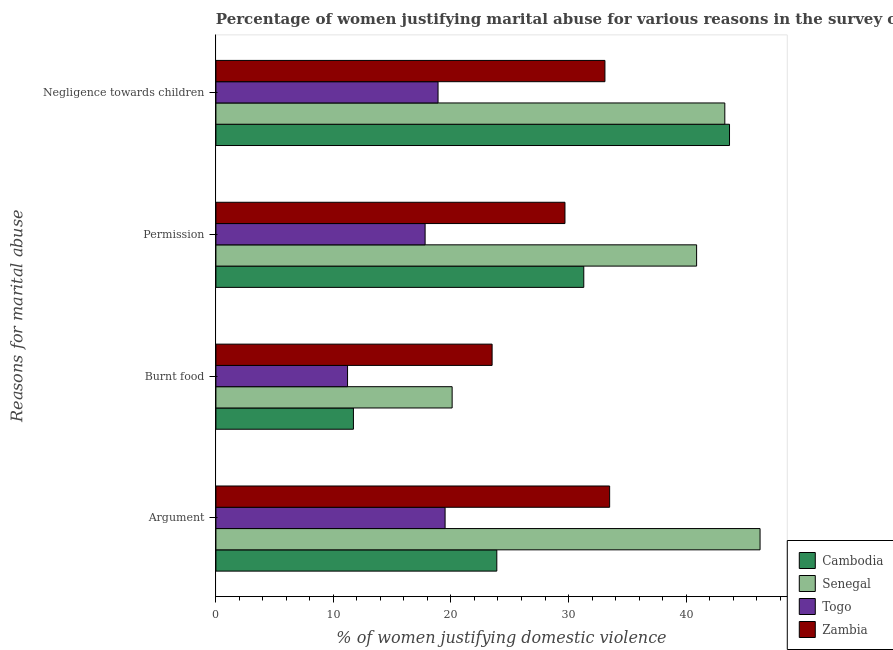How many groups of bars are there?
Provide a short and direct response. 4. Are the number of bars per tick equal to the number of legend labels?
Provide a short and direct response. Yes. Are the number of bars on each tick of the Y-axis equal?
Keep it short and to the point. Yes. How many bars are there on the 3rd tick from the bottom?
Offer a terse response. 4. What is the label of the 1st group of bars from the top?
Your response must be concise. Negligence towards children. What is the percentage of women justifying abuse for going without permission in Zambia?
Keep it short and to the point. 29.7. Across all countries, what is the maximum percentage of women justifying abuse for going without permission?
Ensure brevity in your answer.  40.9. In which country was the percentage of women justifying abuse in the case of an argument maximum?
Your response must be concise. Senegal. In which country was the percentage of women justifying abuse for going without permission minimum?
Provide a succinct answer. Togo. What is the total percentage of women justifying abuse for showing negligence towards children in the graph?
Your answer should be compact. 139. What is the difference between the percentage of women justifying abuse in the case of an argument in Togo and that in Senegal?
Your answer should be compact. -26.8. What is the difference between the percentage of women justifying abuse for showing negligence towards children in Zambia and the percentage of women justifying abuse for burning food in Togo?
Offer a terse response. 21.9. What is the average percentage of women justifying abuse for burning food per country?
Give a very brief answer. 16.62. What is the difference between the percentage of women justifying abuse for showing negligence towards children and percentage of women justifying abuse for burning food in Togo?
Offer a terse response. 7.7. What is the ratio of the percentage of women justifying abuse in the case of an argument in Cambodia to that in Senegal?
Your answer should be compact. 0.52. Is the difference between the percentage of women justifying abuse in the case of an argument in Senegal and Togo greater than the difference between the percentage of women justifying abuse for going without permission in Senegal and Togo?
Offer a very short reply. Yes. What is the difference between the highest and the second highest percentage of women justifying abuse for burning food?
Give a very brief answer. 3.4. In how many countries, is the percentage of women justifying abuse in the case of an argument greater than the average percentage of women justifying abuse in the case of an argument taken over all countries?
Provide a short and direct response. 2. Is it the case that in every country, the sum of the percentage of women justifying abuse in the case of an argument and percentage of women justifying abuse for burning food is greater than the sum of percentage of women justifying abuse for going without permission and percentage of women justifying abuse for showing negligence towards children?
Give a very brief answer. No. What does the 3rd bar from the top in Argument represents?
Offer a terse response. Senegal. What does the 2nd bar from the bottom in Argument represents?
Give a very brief answer. Senegal. Is it the case that in every country, the sum of the percentage of women justifying abuse in the case of an argument and percentage of women justifying abuse for burning food is greater than the percentage of women justifying abuse for going without permission?
Offer a terse response. Yes. How many bars are there?
Make the answer very short. 16. Are all the bars in the graph horizontal?
Provide a succinct answer. Yes. What is the difference between two consecutive major ticks on the X-axis?
Offer a terse response. 10. Are the values on the major ticks of X-axis written in scientific E-notation?
Provide a short and direct response. No. Does the graph contain grids?
Provide a short and direct response. No. Where does the legend appear in the graph?
Your response must be concise. Bottom right. What is the title of the graph?
Give a very brief answer. Percentage of women justifying marital abuse for various reasons in the survey of 2014. What is the label or title of the X-axis?
Make the answer very short. % of women justifying domestic violence. What is the label or title of the Y-axis?
Your response must be concise. Reasons for marital abuse. What is the % of women justifying domestic violence in Cambodia in Argument?
Your answer should be very brief. 23.9. What is the % of women justifying domestic violence in Senegal in Argument?
Your answer should be compact. 46.3. What is the % of women justifying domestic violence in Togo in Argument?
Keep it short and to the point. 19.5. What is the % of women justifying domestic violence of Zambia in Argument?
Give a very brief answer. 33.5. What is the % of women justifying domestic violence of Cambodia in Burnt food?
Keep it short and to the point. 11.7. What is the % of women justifying domestic violence of Senegal in Burnt food?
Provide a succinct answer. 20.1. What is the % of women justifying domestic violence in Cambodia in Permission?
Your response must be concise. 31.3. What is the % of women justifying domestic violence of Senegal in Permission?
Keep it short and to the point. 40.9. What is the % of women justifying domestic violence of Togo in Permission?
Your response must be concise. 17.8. What is the % of women justifying domestic violence in Zambia in Permission?
Offer a terse response. 29.7. What is the % of women justifying domestic violence in Cambodia in Negligence towards children?
Provide a succinct answer. 43.7. What is the % of women justifying domestic violence in Senegal in Negligence towards children?
Your answer should be very brief. 43.3. What is the % of women justifying domestic violence in Togo in Negligence towards children?
Keep it short and to the point. 18.9. What is the % of women justifying domestic violence of Zambia in Negligence towards children?
Offer a very short reply. 33.1. Across all Reasons for marital abuse, what is the maximum % of women justifying domestic violence in Cambodia?
Ensure brevity in your answer.  43.7. Across all Reasons for marital abuse, what is the maximum % of women justifying domestic violence in Senegal?
Give a very brief answer. 46.3. Across all Reasons for marital abuse, what is the maximum % of women justifying domestic violence in Togo?
Give a very brief answer. 19.5. Across all Reasons for marital abuse, what is the maximum % of women justifying domestic violence of Zambia?
Offer a very short reply. 33.5. Across all Reasons for marital abuse, what is the minimum % of women justifying domestic violence in Senegal?
Your answer should be compact. 20.1. Across all Reasons for marital abuse, what is the minimum % of women justifying domestic violence in Togo?
Ensure brevity in your answer.  11.2. What is the total % of women justifying domestic violence in Cambodia in the graph?
Keep it short and to the point. 110.6. What is the total % of women justifying domestic violence in Senegal in the graph?
Give a very brief answer. 150.6. What is the total % of women justifying domestic violence in Togo in the graph?
Your response must be concise. 67.4. What is the total % of women justifying domestic violence of Zambia in the graph?
Ensure brevity in your answer.  119.8. What is the difference between the % of women justifying domestic violence of Cambodia in Argument and that in Burnt food?
Provide a succinct answer. 12.2. What is the difference between the % of women justifying domestic violence of Senegal in Argument and that in Burnt food?
Your answer should be very brief. 26.2. What is the difference between the % of women justifying domestic violence in Cambodia in Argument and that in Permission?
Make the answer very short. -7.4. What is the difference between the % of women justifying domestic violence of Senegal in Argument and that in Permission?
Provide a succinct answer. 5.4. What is the difference between the % of women justifying domestic violence of Zambia in Argument and that in Permission?
Keep it short and to the point. 3.8. What is the difference between the % of women justifying domestic violence in Cambodia in Argument and that in Negligence towards children?
Ensure brevity in your answer.  -19.8. What is the difference between the % of women justifying domestic violence in Zambia in Argument and that in Negligence towards children?
Your answer should be very brief. 0.4. What is the difference between the % of women justifying domestic violence of Cambodia in Burnt food and that in Permission?
Your response must be concise. -19.6. What is the difference between the % of women justifying domestic violence of Senegal in Burnt food and that in Permission?
Make the answer very short. -20.8. What is the difference between the % of women justifying domestic violence of Cambodia in Burnt food and that in Negligence towards children?
Offer a terse response. -32. What is the difference between the % of women justifying domestic violence in Senegal in Burnt food and that in Negligence towards children?
Ensure brevity in your answer.  -23.2. What is the difference between the % of women justifying domestic violence in Zambia in Burnt food and that in Negligence towards children?
Provide a succinct answer. -9.6. What is the difference between the % of women justifying domestic violence of Cambodia in Permission and that in Negligence towards children?
Your response must be concise. -12.4. What is the difference between the % of women justifying domestic violence of Togo in Permission and that in Negligence towards children?
Provide a short and direct response. -1.1. What is the difference between the % of women justifying domestic violence in Zambia in Permission and that in Negligence towards children?
Make the answer very short. -3.4. What is the difference between the % of women justifying domestic violence in Cambodia in Argument and the % of women justifying domestic violence in Senegal in Burnt food?
Offer a very short reply. 3.8. What is the difference between the % of women justifying domestic violence of Senegal in Argument and the % of women justifying domestic violence of Togo in Burnt food?
Offer a terse response. 35.1. What is the difference between the % of women justifying domestic violence of Senegal in Argument and the % of women justifying domestic violence of Zambia in Burnt food?
Ensure brevity in your answer.  22.8. What is the difference between the % of women justifying domestic violence in Senegal in Argument and the % of women justifying domestic violence in Zambia in Permission?
Your answer should be compact. 16.6. What is the difference between the % of women justifying domestic violence of Togo in Argument and the % of women justifying domestic violence of Zambia in Permission?
Your answer should be compact. -10.2. What is the difference between the % of women justifying domestic violence in Cambodia in Argument and the % of women justifying domestic violence in Senegal in Negligence towards children?
Give a very brief answer. -19.4. What is the difference between the % of women justifying domestic violence in Cambodia in Argument and the % of women justifying domestic violence in Togo in Negligence towards children?
Ensure brevity in your answer.  5. What is the difference between the % of women justifying domestic violence in Senegal in Argument and the % of women justifying domestic violence in Togo in Negligence towards children?
Offer a very short reply. 27.4. What is the difference between the % of women justifying domestic violence in Senegal in Argument and the % of women justifying domestic violence in Zambia in Negligence towards children?
Offer a very short reply. 13.2. What is the difference between the % of women justifying domestic violence of Togo in Argument and the % of women justifying domestic violence of Zambia in Negligence towards children?
Provide a short and direct response. -13.6. What is the difference between the % of women justifying domestic violence of Cambodia in Burnt food and the % of women justifying domestic violence of Senegal in Permission?
Offer a terse response. -29.2. What is the difference between the % of women justifying domestic violence of Cambodia in Burnt food and the % of women justifying domestic violence of Togo in Permission?
Offer a terse response. -6.1. What is the difference between the % of women justifying domestic violence of Senegal in Burnt food and the % of women justifying domestic violence of Togo in Permission?
Offer a terse response. 2.3. What is the difference between the % of women justifying domestic violence in Togo in Burnt food and the % of women justifying domestic violence in Zambia in Permission?
Offer a terse response. -18.5. What is the difference between the % of women justifying domestic violence in Cambodia in Burnt food and the % of women justifying domestic violence in Senegal in Negligence towards children?
Offer a terse response. -31.6. What is the difference between the % of women justifying domestic violence in Cambodia in Burnt food and the % of women justifying domestic violence in Zambia in Negligence towards children?
Offer a terse response. -21.4. What is the difference between the % of women justifying domestic violence in Senegal in Burnt food and the % of women justifying domestic violence in Togo in Negligence towards children?
Your answer should be very brief. 1.2. What is the difference between the % of women justifying domestic violence in Togo in Burnt food and the % of women justifying domestic violence in Zambia in Negligence towards children?
Your answer should be compact. -21.9. What is the difference between the % of women justifying domestic violence of Senegal in Permission and the % of women justifying domestic violence of Togo in Negligence towards children?
Keep it short and to the point. 22. What is the difference between the % of women justifying domestic violence in Senegal in Permission and the % of women justifying domestic violence in Zambia in Negligence towards children?
Your answer should be compact. 7.8. What is the difference between the % of women justifying domestic violence in Togo in Permission and the % of women justifying domestic violence in Zambia in Negligence towards children?
Ensure brevity in your answer.  -15.3. What is the average % of women justifying domestic violence of Cambodia per Reasons for marital abuse?
Ensure brevity in your answer.  27.65. What is the average % of women justifying domestic violence of Senegal per Reasons for marital abuse?
Give a very brief answer. 37.65. What is the average % of women justifying domestic violence of Togo per Reasons for marital abuse?
Provide a succinct answer. 16.85. What is the average % of women justifying domestic violence in Zambia per Reasons for marital abuse?
Keep it short and to the point. 29.95. What is the difference between the % of women justifying domestic violence of Cambodia and % of women justifying domestic violence of Senegal in Argument?
Give a very brief answer. -22.4. What is the difference between the % of women justifying domestic violence of Senegal and % of women justifying domestic violence of Togo in Argument?
Offer a very short reply. 26.8. What is the difference between the % of women justifying domestic violence in Cambodia and % of women justifying domestic violence in Togo in Burnt food?
Ensure brevity in your answer.  0.5. What is the difference between the % of women justifying domestic violence of Cambodia and % of women justifying domestic violence of Zambia in Burnt food?
Your response must be concise. -11.8. What is the difference between the % of women justifying domestic violence of Senegal and % of women justifying domestic violence of Zambia in Burnt food?
Give a very brief answer. -3.4. What is the difference between the % of women justifying domestic violence of Togo and % of women justifying domestic violence of Zambia in Burnt food?
Give a very brief answer. -12.3. What is the difference between the % of women justifying domestic violence in Cambodia and % of women justifying domestic violence in Togo in Permission?
Make the answer very short. 13.5. What is the difference between the % of women justifying domestic violence in Cambodia and % of women justifying domestic violence in Zambia in Permission?
Provide a short and direct response. 1.6. What is the difference between the % of women justifying domestic violence of Senegal and % of women justifying domestic violence of Togo in Permission?
Your answer should be compact. 23.1. What is the difference between the % of women justifying domestic violence of Cambodia and % of women justifying domestic violence of Senegal in Negligence towards children?
Your answer should be very brief. 0.4. What is the difference between the % of women justifying domestic violence of Cambodia and % of women justifying domestic violence of Togo in Negligence towards children?
Offer a very short reply. 24.8. What is the difference between the % of women justifying domestic violence of Senegal and % of women justifying domestic violence of Togo in Negligence towards children?
Ensure brevity in your answer.  24.4. What is the difference between the % of women justifying domestic violence in Senegal and % of women justifying domestic violence in Zambia in Negligence towards children?
Provide a succinct answer. 10.2. What is the ratio of the % of women justifying domestic violence in Cambodia in Argument to that in Burnt food?
Make the answer very short. 2.04. What is the ratio of the % of women justifying domestic violence in Senegal in Argument to that in Burnt food?
Your response must be concise. 2.3. What is the ratio of the % of women justifying domestic violence in Togo in Argument to that in Burnt food?
Provide a succinct answer. 1.74. What is the ratio of the % of women justifying domestic violence in Zambia in Argument to that in Burnt food?
Your answer should be compact. 1.43. What is the ratio of the % of women justifying domestic violence of Cambodia in Argument to that in Permission?
Your answer should be compact. 0.76. What is the ratio of the % of women justifying domestic violence of Senegal in Argument to that in Permission?
Make the answer very short. 1.13. What is the ratio of the % of women justifying domestic violence of Togo in Argument to that in Permission?
Make the answer very short. 1.1. What is the ratio of the % of women justifying domestic violence of Zambia in Argument to that in Permission?
Offer a very short reply. 1.13. What is the ratio of the % of women justifying domestic violence of Cambodia in Argument to that in Negligence towards children?
Your response must be concise. 0.55. What is the ratio of the % of women justifying domestic violence of Senegal in Argument to that in Negligence towards children?
Your answer should be compact. 1.07. What is the ratio of the % of women justifying domestic violence of Togo in Argument to that in Negligence towards children?
Make the answer very short. 1.03. What is the ratio of the % of women justifying domestic violence in Zambia in Argument to that in Negligence towards children?
Offer a terse response. 1.01. What is the ratio of the % of women justifying domestic violence of Cambodia in Burnt food to that in Permission?
Offer a very short reply. 0.37. What is the ratio of the % of women justifying domestic violence of Senegal in Burnt food to that in Permission?
Offer a very short reply. 0.49. What is the ratio of the % of women justifying domestic violence in Togo in Burnt food to that in Permission?
Offer a terse response. 0.63. What is the ratio of the % of women justifying domestic violence in Zambia in Burnt food to that in Permission?
Provide a short and direct response. 0.79. What is the ratio of the % of women justifying domestic violence in Cambodia in Burnt food to that in Negligence towards children?
Provide a short and direct response. 0.27. What is the ratio of the % of women justifying domestic violence of Senegal in Burnt food to that in Negligence towards children?
Make the answer very short. 0.46. What is the ratio of the % of women justifying domestic violence in Togo in Burnt food to that in Negligence towards children?
Make the answer very short. 0.59. What is the ratio of the % of women justifying domestic violence in Zambia in Burnt food to that in Negligence towards children?
Give a very brief answer. 0.71. What is the ratio of the % of women justifying domestic violence of Cambodia in Permission to that in Negligence towards children?
Your answer should be compact. 0.72. What is the ratio of the % of women justifying domestic violence of Senegal in Permission to that in Negligence towards children?
Your answer should be very brief. 0.94. What is the ratio of the % of women justifying domestic violence in Togo in Permission to that in Negligence towards children?
Your answer should be very brief. 0.94. What is the ratio of the % of women justifying domestic violence of Zambia in Permission to that in Negligence towards children?
Offer a very short reply. 0.9. What is the difference between the highest and the lowest % of women justifying domestic violence of Senegal?
Keep it short and to the point. 26.2. What is the difference between the highest and the lowest % of women justifying domestic violence of Togo?
Your answer should be very brief. 8.3. 